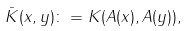Convert formula to latex. <formula><loc_0><loc_0><loc_500><loc_500>\bar { K } ( x , y ) \colon = K ( A ( x ) , A ( y ) ) ,</formula> 